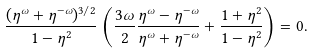<formula> <loc_0><loc_0><loc_500><loc_500>\frac { ( \eta ^ { \omega } + \eta ^ { - \omega } ) ^ { 3 / 2 } } { 1 - \eta ^ { 2 } } \left ( \frac { 3 \omega } 2 \frac { \eta ^ { \omega } - \eta ^ { - \omega } } { \eta ^ { \omega } + \eta ^ { - \omega } } + \frac { 1 + \eta ^ { 2 } } { 1 - \eta ^ { 2 } } \right ) = 0 .</formula> 